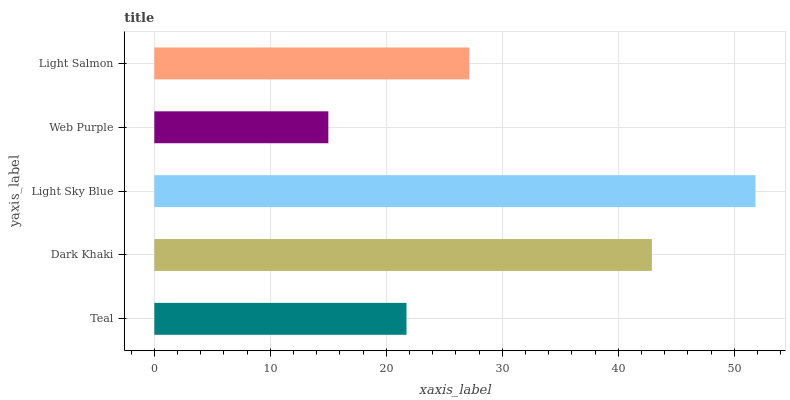Is Web Purple the minimum?
Answer yes or no. Yes. Is Light Sky Blue the maximum?
Answer yes or no. Yes. Is Dark Khaki the minimum?
Answer yes or no. No. Is Dark Khaki the maximum?
Answer yes or no. No. Is Dark Khaki greater than Teal?
Answer yes or no. Yes. Is Teal less than Dark Khaki?
Answer yes or no. Yes. Is Teal greater than Dark Khaki?
Answer yes or no. No. Is Dark Khaki less than Teal?
Answer yes or no. No. Is Light Salmon the high median?
Answer yes or no. Yes. Is Light Salmon the low median?
Answer yes or no. Yes. Is Light Sky Blue the high median?
Answer yes or no. No. Is Teal the low median?
Answer yes or no. No. 